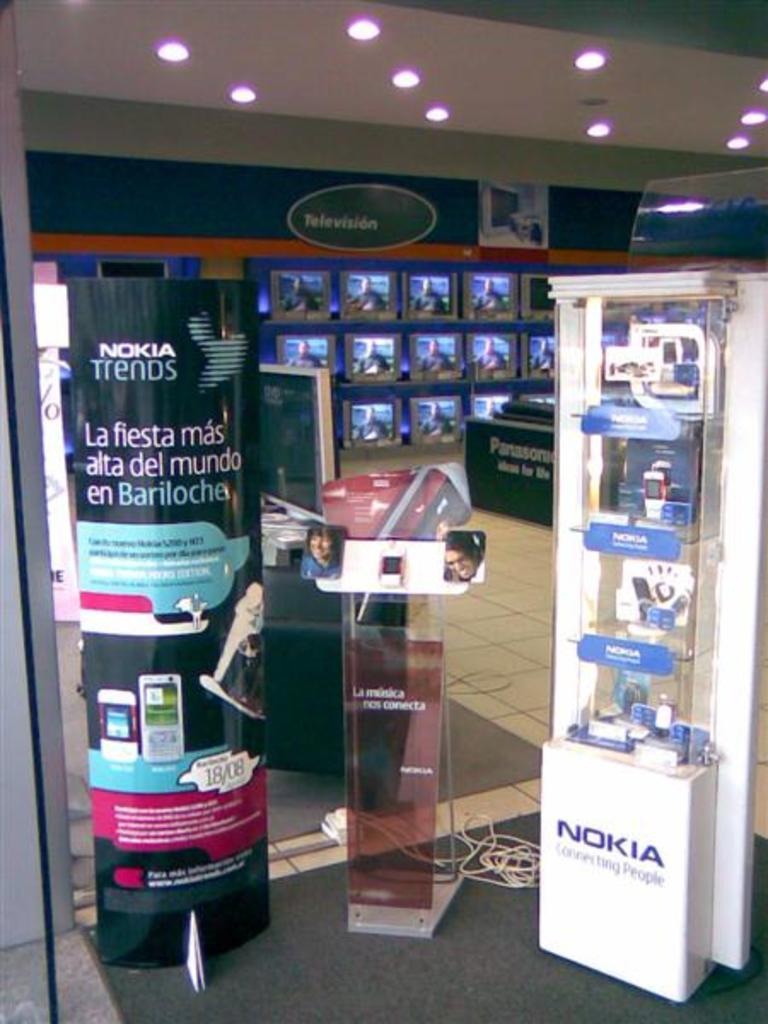Describe this image in one or two sentences. This picture is clicked inside the hall. On the left there is a banner and we can see the text, numbers and the depictions of the devices and the depictions of some objects on the banner. In the center there is an object on which we can see the text and the depictions of two people. On the right we can see a cabinet containing the mobile phones and we can see the text on the cabinet. At the top there is a roof and the ceiling lights. In the background we can see the digital screens and we can see the depictions of the person and some objects on the digital screens. On the right there is an object which seems to be the table and we can see the text on the table and we can see the ground and some other objects. 